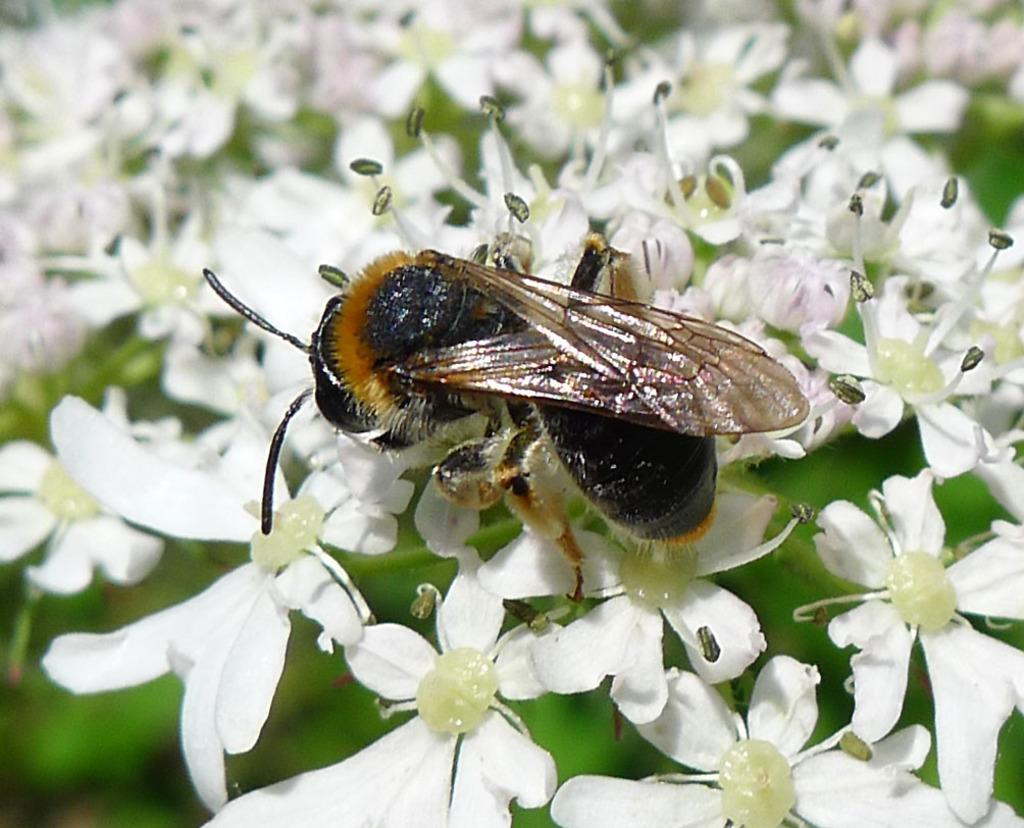What type of flowers can be seen in the image? There are white flowers in the image. What other living organism is present in the image? There is a black insect in the image. How would you describe the overall clarity of the image? The image is blurry in the background. What type of impulse can be seen affecting the oven in the image? There is no oven present in the image, and therefore no impulse affecting it. 